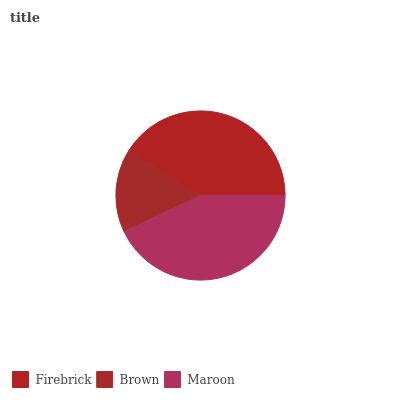Is Brown the minimum?
Answer yes or no. Yes. Is Maroon the maximum?
Answer yes or no. Yes. Is Maroon the minimum?
Answer yes or no. No. Is Brown the maximum?
Answer yes or no. No. Is Maroon greater than Brown?
Answer yes or no. Yes. Is Brown less than Maroon?
Answer yes or no. Yes. Is Brown greater than Maroon?
Answer yes or no. No. Is Maroon less than Brown?
Answer yes or no. No. Is Firebrick the high median?
Answer yes or no. Yes. Is Firebrick the low median?
Answer yes or no. Yes. Is Maroon the high median?
Answer yes or no. No. Is Maroon the low median?
Answer yes or no. No. 